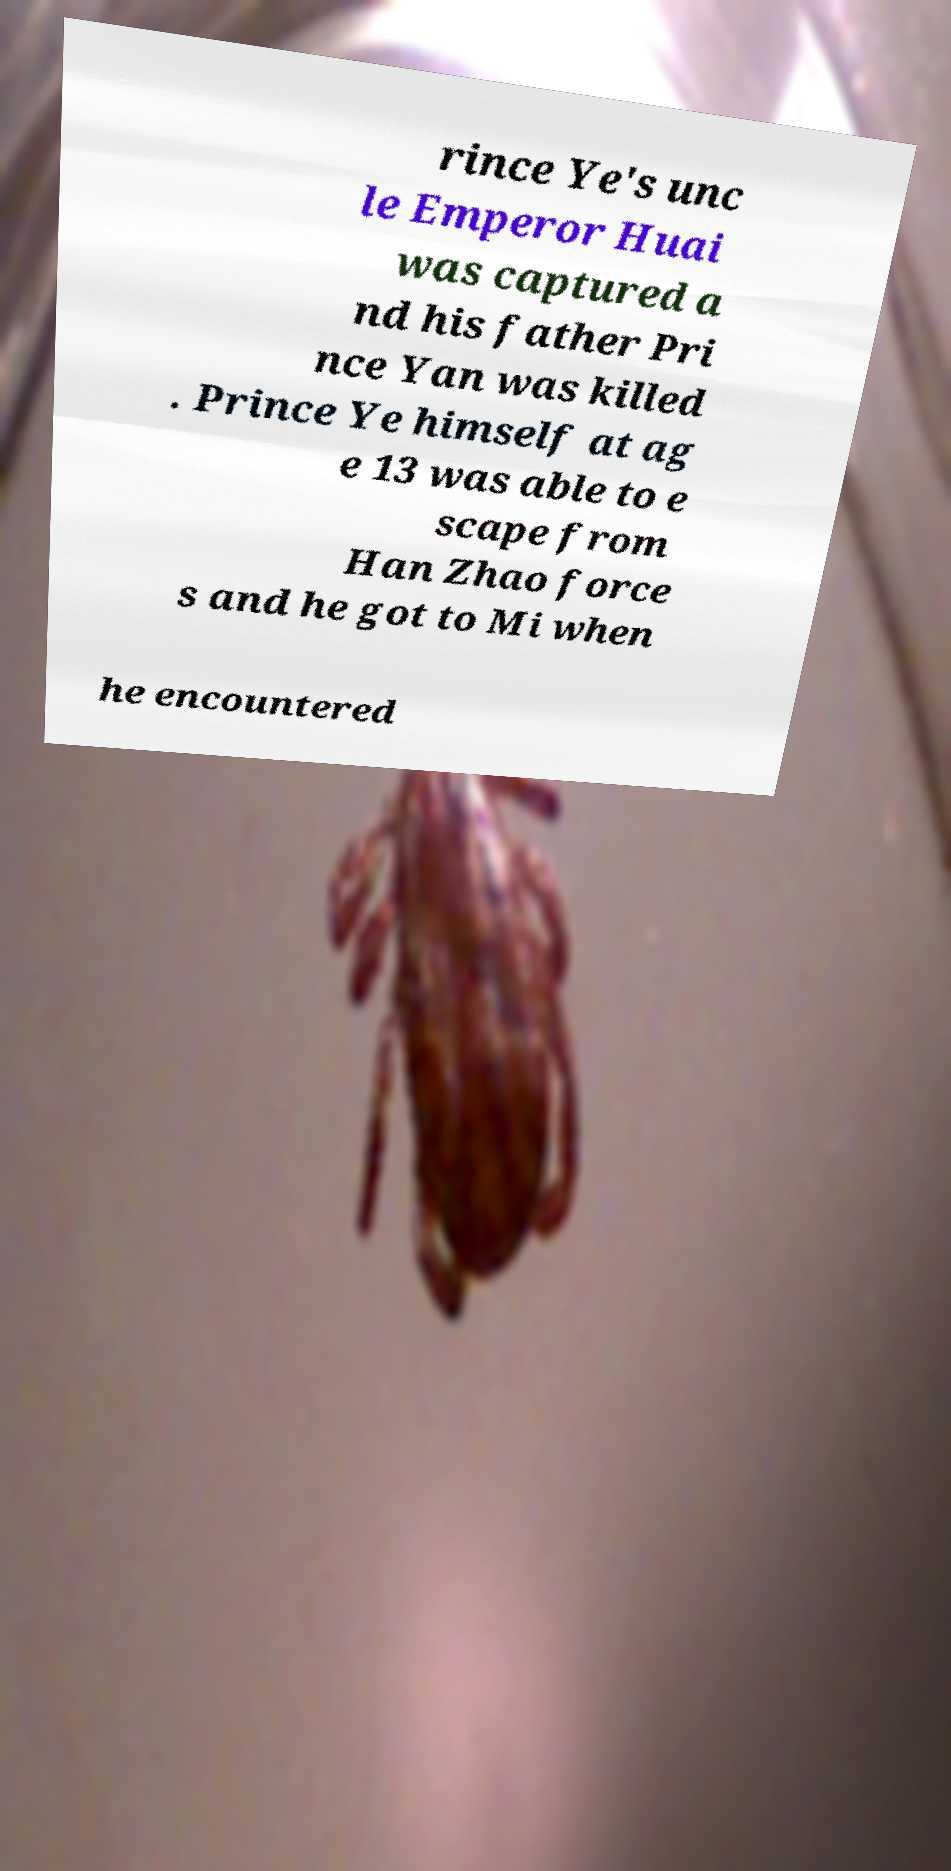For documentation purposes, I need the text within this image transcribed. Could you provide that? rince Ye's unc le Emperor Huai was captured a nd his father Pri nce Yan was killed . Prince Ye himself at ag e 13 was able to e scape from Han Zhao force s and he got to Mi when he encountered 